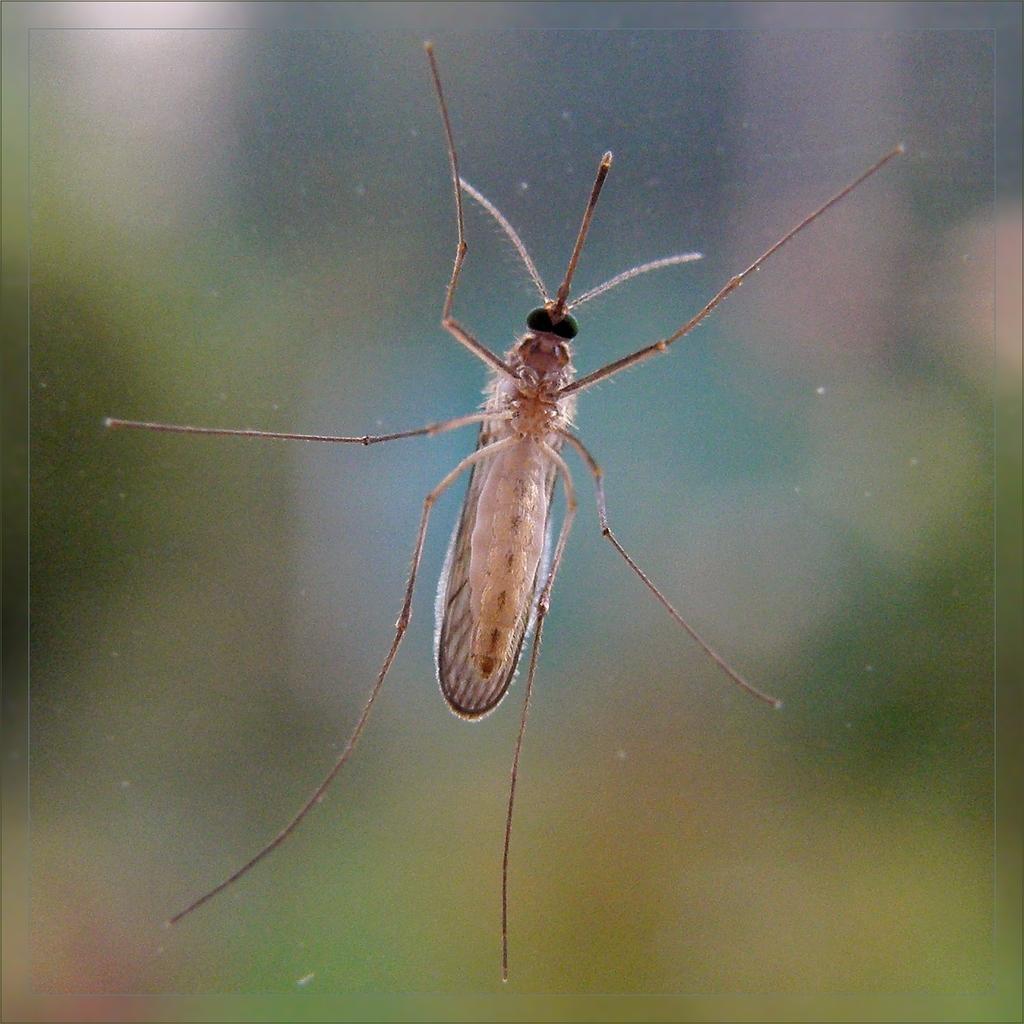Could you give a brief overview of what you see in this image? In the center of the picture we can see a mosquito on the glass. The background is blurred. 